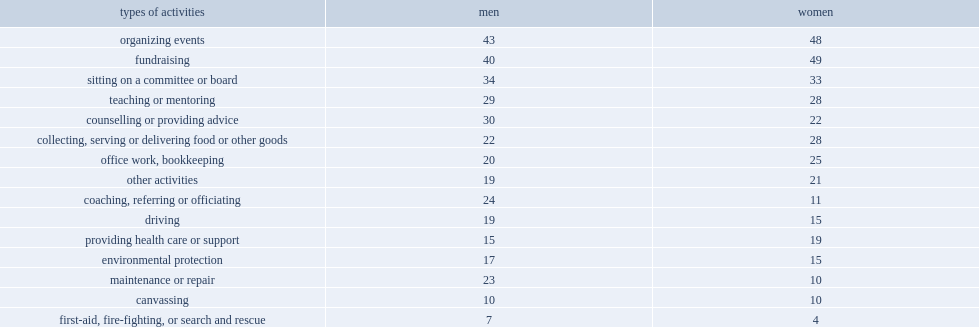Which sex are more involved in fundraising? Women. Which sex are more involved in organizing events? Women. Which sex are more involved in providing health care? Women. How many times is the probability of men to coach than that of women? 2.181818. How many times is the probability of men to provide services related to maintenance or repair than that of women? 2.3. 